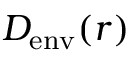<formula> <loc_0><loc_0><loc_500><loc_500>D _ { e n v } ( r )</formula> 